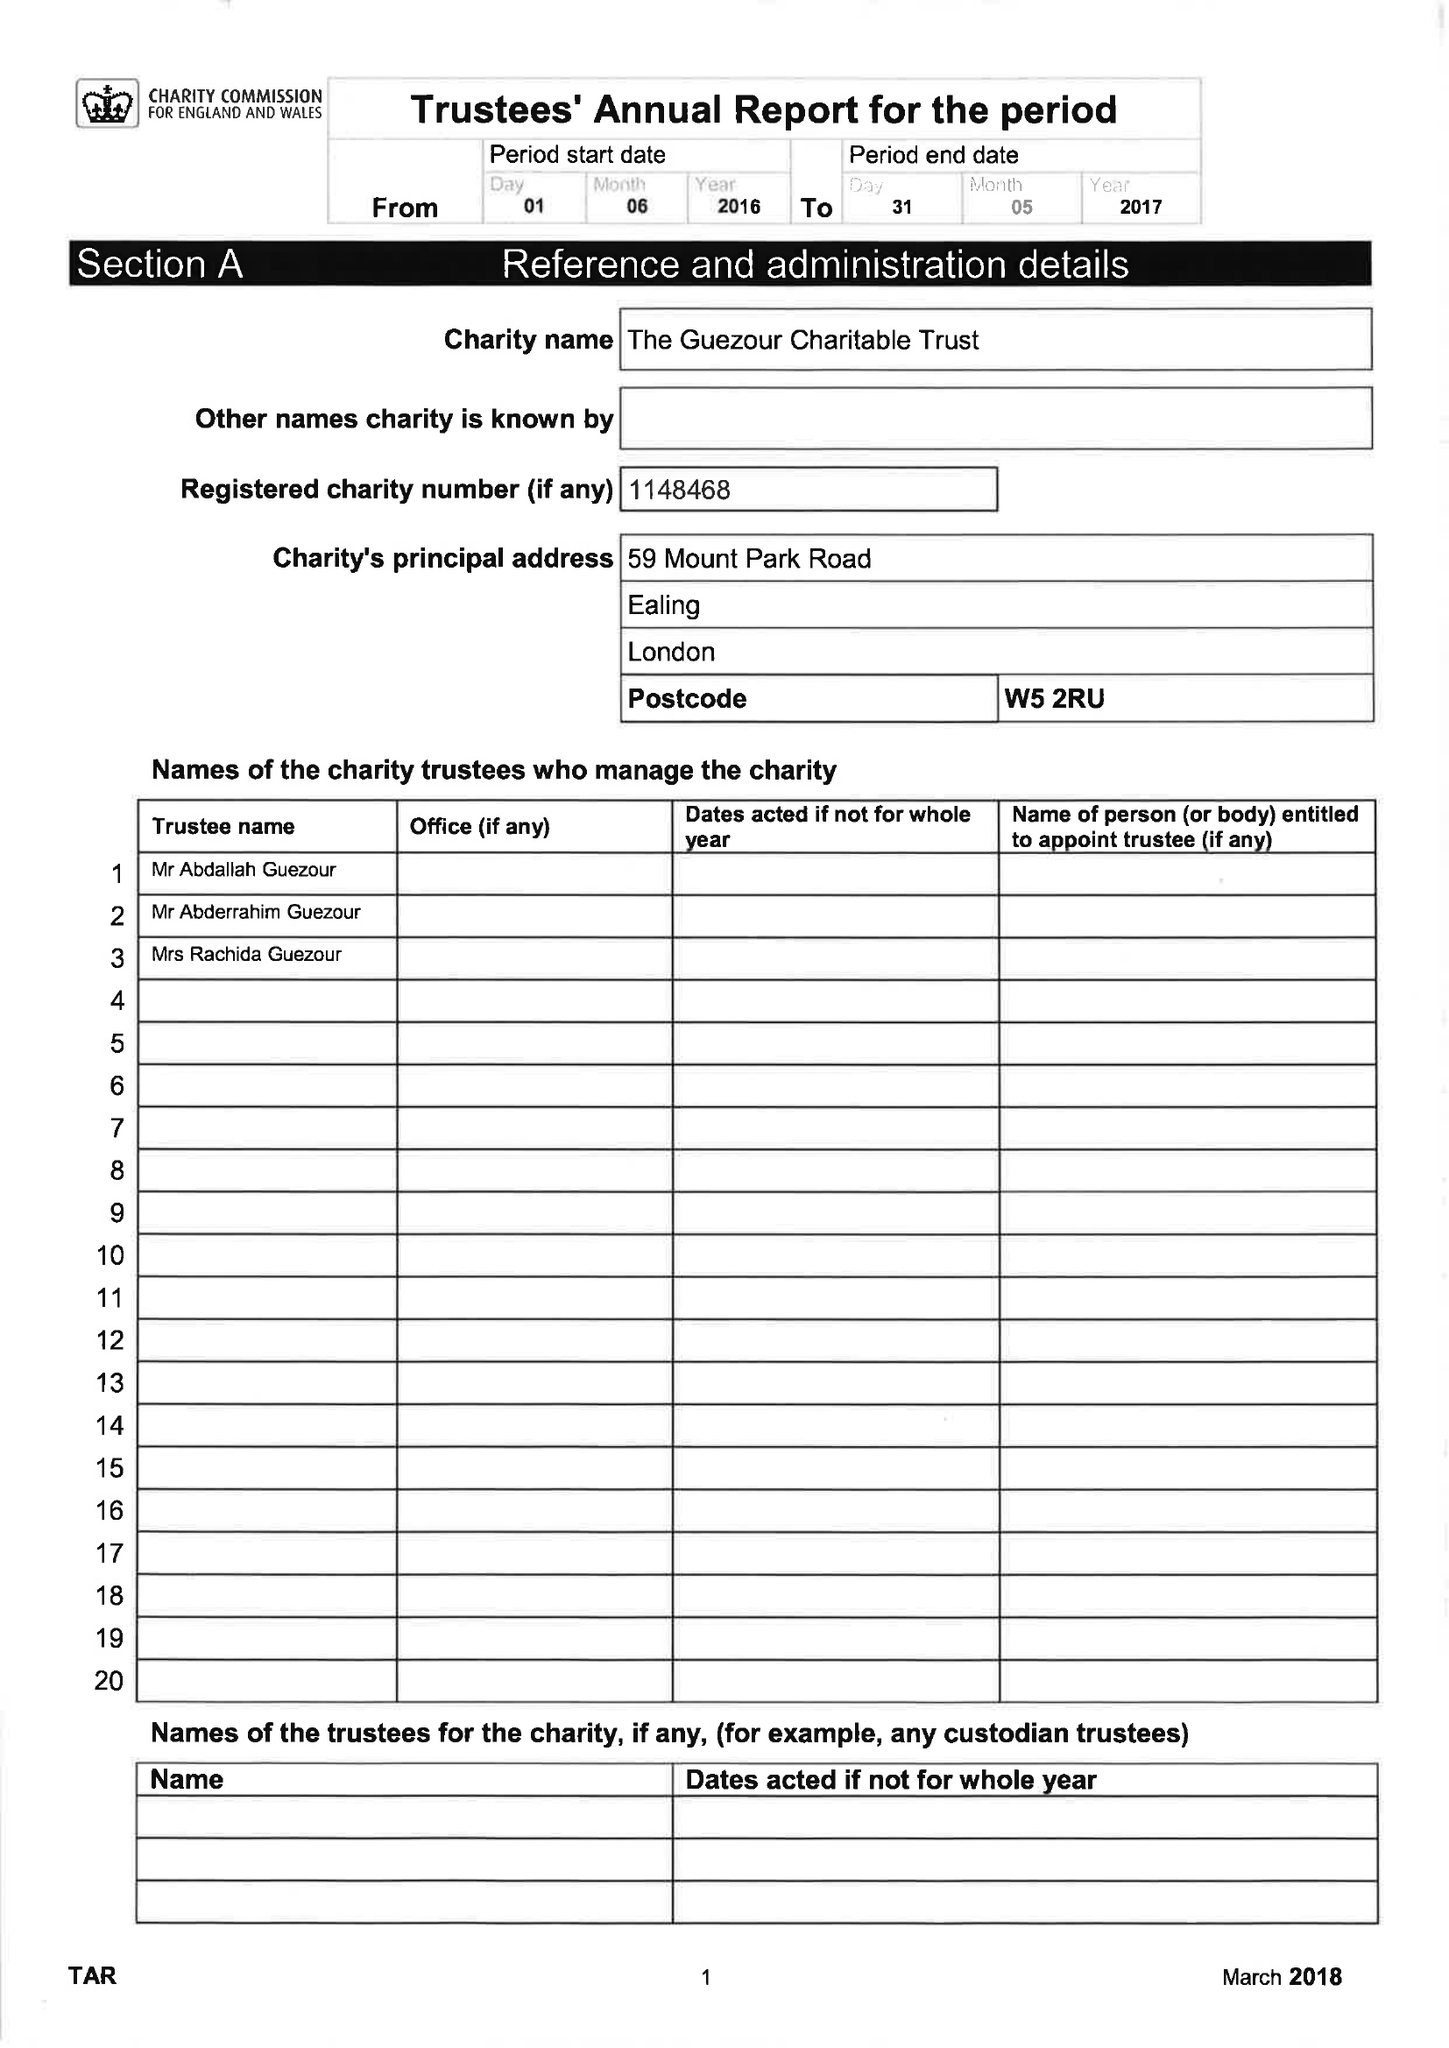What is the value for the address__post_town?
Answer the question using a single word or phrase. LONDON 